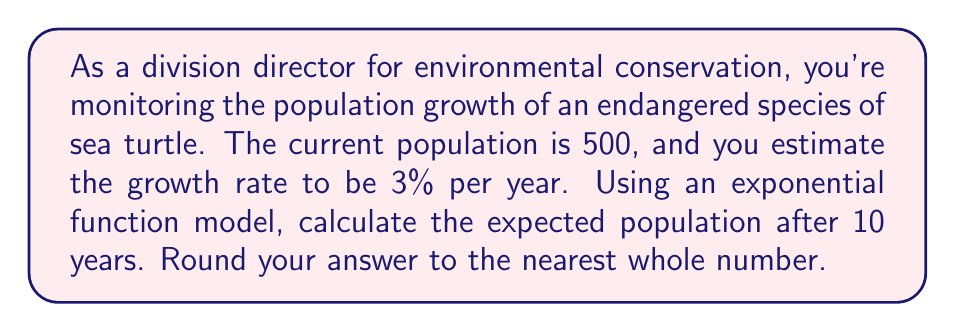Provide a solution to this math problem. To solve this problem, we'll use the exponential growth function:

$$P(t) = P_0 \cdot (1 + r)^t$$

Where:
$P(t)$ is the population at time $t$
$P_0$ is the initial population
$r$ is the growth rate (as a decimal)
$t$ is the time in years

Given:
$P_0 = 500$ (initial population)
$r = 0.03$ (3% growth rate)
$t = 10$ years

Let's substitute these values into the equation:

$$P(10) = 500 \cdot (1 + 0.03)^{10}$$

Now, let's calculate step by step:

1) First, calculate $(1 + 0.03)^{10}$:
   $$(1.03)^{10} \approx 1.3439$$

2) Multiply this by the initial population:
   $$500 \cdot 1.3439 \approx 671.95$$

3) Round to the nearest whole number:
   $$671.95 \approx 672$$

Therefore, the expected population after 10 years is approximately 672 sea turtles.
Answer: 672 sea turtles 